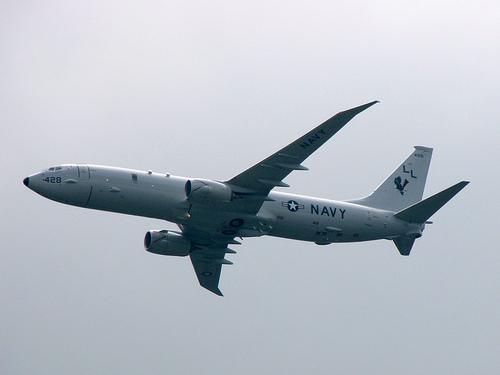How many planes?
Give a very brief answer. 1. 